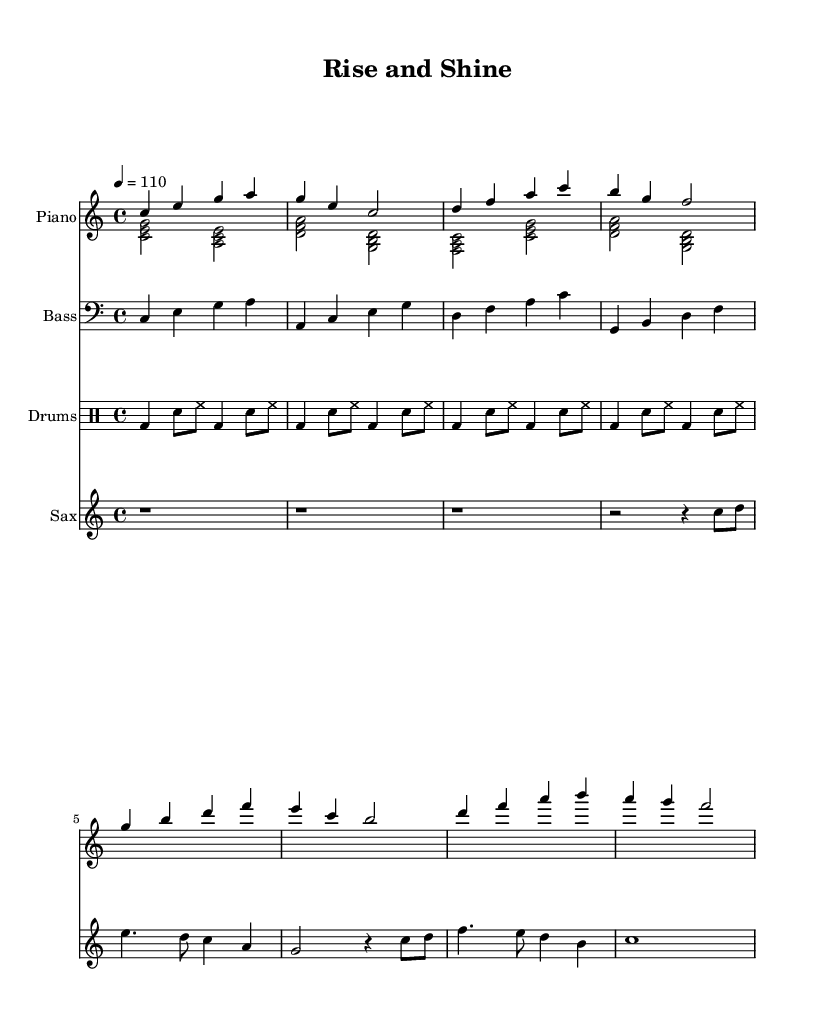What is the key signature of this music? The key signature is C major, which has no sharps or flats.
Answer: C major What is the time signature of this piece? The time signature is shown as 4/4, indicating there are four beats in a measure.
Answer: 4/4 What is the tempo marking of the piece? The tempo is marked as quarter note equals 110, which indicates the speed of the piece.
Answer: 110 How many measures are in the saxophone part? The saxophone part has 8 measures, as counted from the beginning to the end of the notation provided.
Answer: 8 Which instruments are featured in this score? The score includes piano, bass, drums, and saxophone as indicated by their respective staves.
Answer: Piano, bass, drums, saxophone What type of chords are played in the left hand of the piano? The left hand of the piano plays triads, which consist of three notes forming chords.
Answer: Triads What rhythmic figure is most prevalent in the drums part? The prevalent rhythmic figure in the drums part is the bass drum and snare combination which is repeated throughout the piece.
Answer: Bass drum and snare combination 